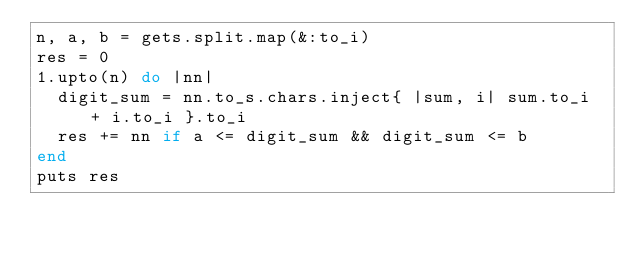<code> <loc_0><loc_0><loc_500><loc_500><_Ruby_>n, a, b = gets.split.map(&:to_i)
res = 0
1.upto(n) do |nn|
  digit_sum = nn.to_s.chars.inject{ |sum, i| sum.to_i + i.to_i }.to_i
  res += nn if a <= digit_sum && digit_sum <= b
end
puts res</code> 